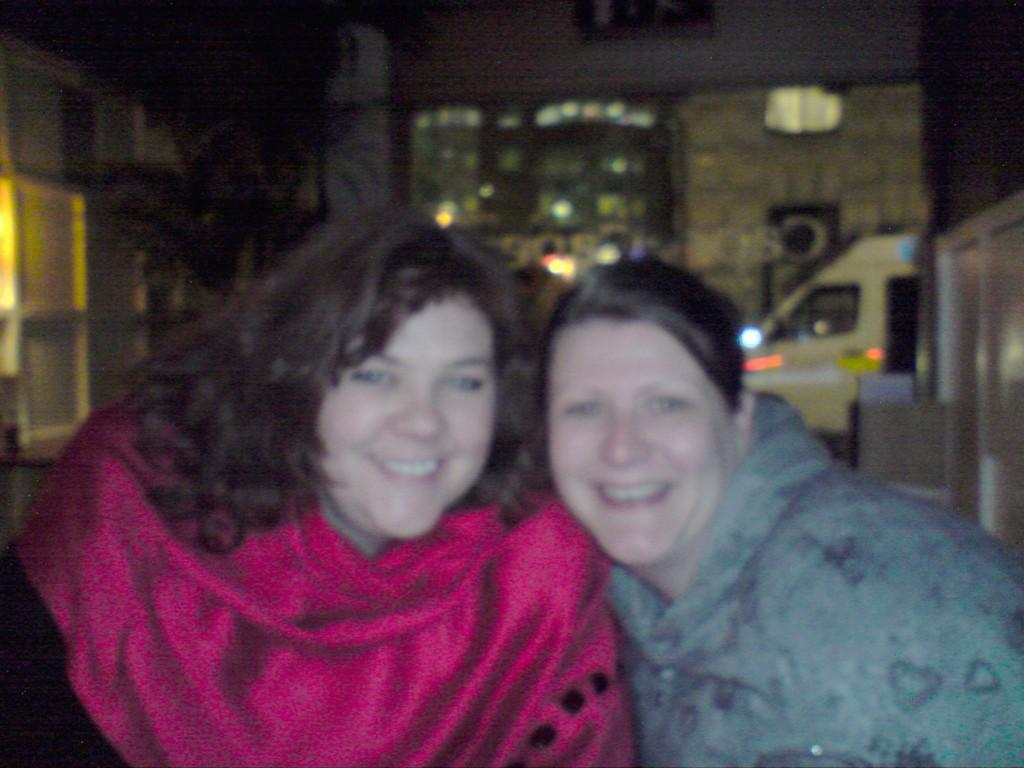Who can be seen in the center of the image? There are two ladies in the center of the image. What is the facial expression of the ladies? The ladies are smiling. What can be seen in the background of the image? There are buildings, a door, a tree, a wall, a vehicle, and lights in the background of the image. What type of crime is being committed in the image? There is no crime being committed in the image; it features two smiling ladies and a background with various elements. Can you tell me how many jellyfish are swimming in the background of the image? There are no jellyfish present in the image; it features a background with buildings, a door, a tree, a wall, a vehicle, and lights. 